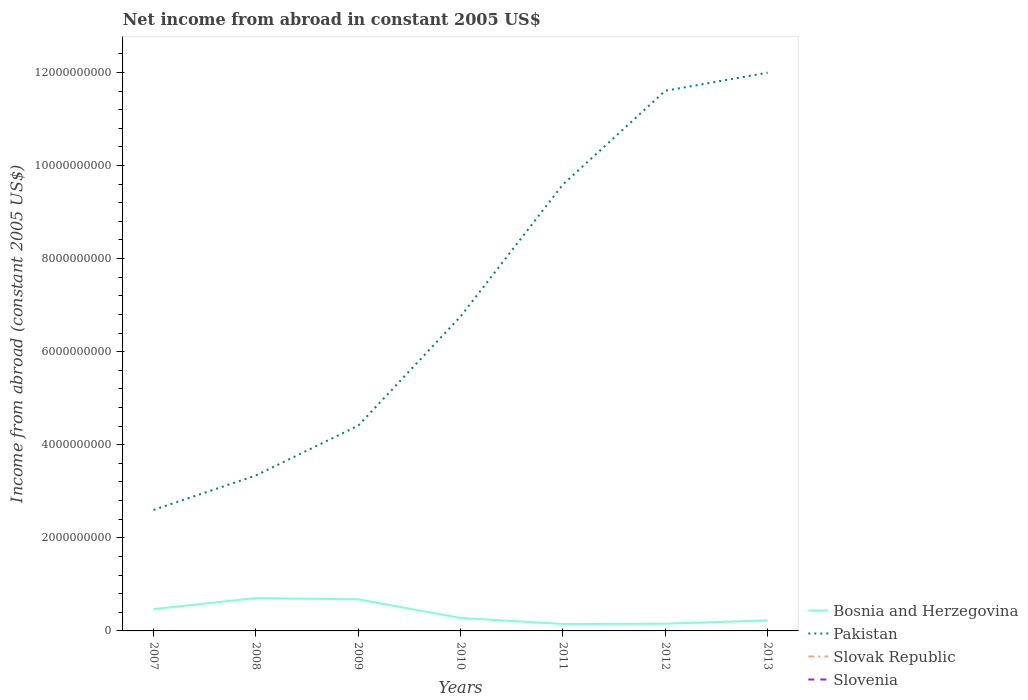How many different coloured lines are there?
Give a very brief answer. 2. Across all years, what is the maximum net income from abroad in Pakistan?
Offer a terse response. 2.60e+09. What is the total net income from abroad in Bosnia and Herzegovina in the graph?
Ensure brevity in your answer.  1.89e+08. What is the difference between the highest and the second highest net income from abroad in Bosnia and Herzegovina?
Your answer should be compact. 5.58e+08. What is the difference between the highest and the lowest net income from abroad in Slovenia?
Give a very brief answer. 0. Is the net income from abroad in Slovenia strictly greater than the net income from abroad in Slovak Republic over the years?
Provide a short and direct response. No. How many lines are there?
Make the answer very short. 2. What is the difference between two consecutive major ticks on the Y-axis?
Provide a succinct answer. 2.00e+09. Does the graph contain any zero values?
Make the answer very short. Yes. Does the graph contain grids?
Your answer should be compact. No. How many legend labels are there?
Offer a terse response. 4. How are the legend labels stacked?
Make the answer very short. Vertical. What is the title of the graph?
Your response must be concise. Net income from abroad in constant 2005 US$. Does "Australia" appear as one of the legend labels in the graph?
Give a very brief answer. No. What is the label or title of the Y-axis?
Your answer should be very brief. Income from abroad (constant 2005 US$). What is the Income from abroad (constant 2005 US$) of Bosnia and Herzegovina in 2007?
Keep it short and to the point. 4.69e+08. What is the Income from abroad (constant 2005 US$) of Pakistan in 2007?
Give a very brief answer. 2.60e+09. What is the Income from abroad (constant 2005 US$) of Slovak Republic in 2007?
Make the answer very short. 0. What is the Income from abroad (constant 2005 US$) in Slovenia in 2007?
Make the answer very short. 0. What is the Income from abroad (constant 2005 US$) of Bosnia and Herzegovina in 2008?
Your answer should be compact. 7.06e+08. What is the Income from abroad (constant 2005 US$) of Pakistan in 2008?
Offer a terse response. 3.34e+09. What is the Income from abroad (constant 2005 US$) in Slovak Republic in 2008?
Offer a very short reply. 0. What is the Income from abroad (constant 2005 US$) in Slovenia in 2008?
Keep it short and to the point. 0. What is the Income from abroad (constant 2005 US$) of Bosnia and Herzegovina in 2009?
Your answer should be very brief. 6.78e+08. What is the Income from abroad (constant 2005 US$) of Pakistan in 2009?
Your response must be concise. 4.41e+09. What is the Income from abroad (constant 2005 US$) in Slovenia in 2009?
Your answer should be very brief. 0. What is the Income from abroad (constant 2005 US$) of Bosnia and Herzegovina in 2010?
Make the answer very short. 2.79e+08. What is the Income from abroad (constant 2005 US$) in Pakistan in 2010?
Your answer should be compact. 6.76e+09. What is the Income from abroad (constant 2005 US$) of Slovenia in 2010?
Your response must be concise. 0. What is the Income from abroad (constant 2005 US$) in Bosnia and Herzegovina in 2011?
Offer a very short reply. 1.49e+08. What is the Income from abroad (constant 2005 US$) in Pakistan in 2011?
Your response must be concise. 9.59e+09. What is the Income from abroad (constant 2005 US$) in Bosnia and Herzegovina in 2012?
Your response must be concise. 1.55e+08. What is the Income from abroad (constant 2005 US$) in Pakistan in 2012?
Your response must be concise. 1.16e+1. What is the Income from abroad (constant 2005 US$) in Slovak Republic in 2012?
Your response must be concise. 0. What is the Income from abroad (constant 2005 US$) in Slovenia in 2012?
Your response must be concise. 0. What is the Income from abroad (constant 2005 US$) of Bosnia and Herzegovina in 2013?
Your answer should be very brief. 2.26e+08. What is the Income from abroad (constant 2005 US$) in Pakistan in 2013?
Give a very brief answer. 1.20e+1. What is the Income from abroad (constant 2005 US$) of Slovenia in 2013?
Make the answer very short. 0. Across all years, what is the maximum Income from abroad (constant 2005 US$) of Bosnia and Herzegovina?
Ensure brevity in your answer.  7.06e+08. Across all years, what is the maximum Income from abroad (constant 2005 US$) of Pakistan?
Your response must be concise. 1.20e+1. Across all years, what is the minimum Income from abroad (constant 2005 US$) in Bosnia and Herzegovina?
Provide a succinct answer. 1.49e+08. Across all years, what is the minimum Income from abroad (constant 2005 US$) of Pakistan?
Provide a short and direct response. 2.60e+09. What is the total Income from abroad (constant 2005 US$) in Bosnia and Herzegovina in the graph?
Make the answer very short. 2.66e+09. What is the total Income from abroad (constant 2005 US$) of Pakistan in the graph?
Provide a short and direct response. 5.03e+1. What is the total Income from abroad (constant 2005 US$) in Slovak Republic in the graph?
Keep it short and to the point. 0. What is the total Income from abroad (constant 2005 US$) of Slovenia in the graph?
Make the answer very short. 0. What is the difference between the Income from abroad (constant 2005 US$) of Bosnia and Herzegovina in 2007 and that in 2008?
Provide a succinct answer. -2.38e+08. What is the difference between the Income from abroad (constant 2005 US$) of Pakistan in 2007 and that in 2008?
Your answer should be compact. -7.40e+08. What is the difference between the Income from abroad (constant 2005 US$) of Bosnia and Herzegovina in 2007 and that in 2009?
Your answer should be compact. -2.10e+08. What is the difference between the Income from abroad (constant 2005 US$) in Pakistan in 2007 and that in 2009?
Ensure brevity in your answer.  -1.81e+09. What is the difference between the Income from abroad (constant 2005 US$) in Bosnia and Herzegovina in 2007 and that in 2010?
Provide a succinct answer. 1.89e+08. What is the difference between the Income from abroad (constant 2005 US$) in Pakistan in 2007 and that in 2010?
Give a very brief answer. -4.16e+09. What is the difference between the Income from abroad (constant 2005 US$) in Bosnia and Herzegovina in 2007 and that in 2011?
Provide a succinct answer. 3.20e+08. What is the difference between the Income from abroad (constant 2005 US$) of Pakistan in 2007 and that in 2011?
Offer a very short reply. -6.99e+09. What is the difference between the Income from abroad (constant 2005 US$) of Bosnia and Herzegovina in 2007 and that in 2012?
Offer a terse response. 3.14e+08. What is the difference between the Income from abroad (constant 2005 US$) in Pakistan in 2007 and that in 2012?
Your answer should be very brief. -9.01e+09. What is the difference between the Income from abroad (constant 2005 US$) of Bosnia and Herzegovina in 2007 and that in 2013?
Provide a succinct answer. 2.42e+08. What is the difference between the Income from abroad (constant 2005 US$) of Pakistan in 2007 and that in 2013?
Offer a terse response. -9.40e+09. What is the difference between the Income from abroad (constant 2005 US$) in Bosnia and Herzegovina in 2008 and that in 2009?
Provide a short and direct response. 2.77e+07. What is the difference between the Income from abroad (constant 2005 US$) of Pakistan in 2008 and that in 2009?
Your response must be concise. -1.07e+09. What is the difference between the Income from abroad (constant 2005 US$) of Bosnia and Herzegovina in 2008 and that in 2010?
Ensure brevity in your answer.  4.27e+08. What is the difference between the Income from abroad (constant 2005 US$) in Pakistan in 2008 and that in 2010?
Keep it short and to the point. -3.42e+09. What is the difference between the Income from abroad (constant 2005 US$) in Bosnia and Herzegovina in 2008 and that in 2011?
Offer a terse response. 5.58e+08. What is the difference between the Income from abroad (constant 2005 US$) of Pakistan in 2008 and that in 2011?
Give a very brief answer. -6.25e+09. What is the difference between the Income from abroad (constant 2005 US$) of Bosnia and Herzegovina in 2008 and that in 2012?
Provide a short and direct response. 5.52e+08. What is the difference between the Income from abroad (constant 2005 US$) of Pakistan in 2008 and that in 2012?
Your answer should be compact. -8.27e+09. What is the difference between the Income from abroad (constant 2005 US$) of Bosnia and Herzegovina in 2008 and that in 2013?
Ensure brevity in your answer.  4.80e+08. What is the difference between the Income from abroad (constant 2005 US$) of Pakistan in 2008 and that in 2013?
Provide a succinct answer. -8.65e+09. What is the difference between the Income from abroad (constant 2005 US$) of Bosnia and Herzegovina in 2009 and that in 2010?
Provide a short and direct response. 3.99e+08. What is the difference between the Income from abroad (constant 2005 US$) of Pakistan in 2009 and that in 2010?
Ensure brevity in your answer.  -2.35e+09. What is the difference between the Income from abroad (constant 2005 US$) of Bosnia and Herzegovina in 2009 and that in 2011?
Your response must be concise. 5.30e+08. What is the difference between the Income from abroad (constant 2005 US$) in Pakistan in 2009 and that in 2011?
Ensure brevity in your answer.  -5.18e+09. What is the difference between the Income from abroad (constant 2005 US$) in Bosnia and Herzegovina in 2009 and that in 2012?
Your answer should be very brief. 5.24e+08. What is the difference between the Income from abroad (constant 2005 US$) of Pakistan in 2009 and that in 2012?
Your answer should be very brief. -7.20e+09. What is the difference between the Income from abroad (constant 2005 US$) in Bosnia and Herzegovina in 2009 and that in 2013?
Your answer should be very brief. 4.52e+08. What is the difference between the Income from abroad (constant 2005 US$) of Pakistan in 2009 and that in 2013?
Give a very brief answer. -7.58e+09. What is the difference between the Income from abroad (constant 2005 US$) in Bosnia and Herzegovina in 2010 and that in 2011?
Offer a terse response. 1.31e+08. What is the difference between the Income from abroad (constant 2005 US$) of Pakistan in 2010 and that in 2011?
Ensure brevity in your answer.  -2.84e+09. What is the difference between the Income from abroad (constant 2005 US$) of Bosnia and Herzegovina in 2010 and that in 2012?
Your answer should be compact. 1.25e+08. What is the difference between the Income from abroad (constant 2005 US$) in Pakistan in 2010 and that in 2012?
Your answer should be very brief. -4.85e+09. What is the difference between the Income from abroad (constant 2005 US$) of Bosnia and Herzegovina in 2010 and that in 2013?
Provide a short and direct response. 5.29e+07. What is the difference between the Income from abroad (constant 2005 US$) in Pakistan in 2010 and that in 2013?
Offer a very short reply. -5.24e+09. What is the difference between the Income from abroad (constant 2005 US$) of Bosnia and Herzegovina in 2011 and that in 2012?
Your response must be concise. -6.13e+06. What is the difference between the Income from abroad (constant 2005 US$) of Pakistan in 2011 and that in 2012?
Your response must be concise. -2.01e+09. What is the difference between the Income from abroad (constant 2005 US$) in Bosnia and Herzegovina in 2011 and that in 2013?
Your response must be concise. -7.79e+07. What is the difference between the Income from abroad (constant 2005 US$) in Pakistan in 2011 and that in 2013?
Offer a terse response. -2.40e+09. What is the difference between the Income from abroad (constant 2005 US$) in Bosnia and Herzegovina in 2012 and that in 2013?
Provide a succinct answer. -7.17e+07. What is the difference between the Income from abroad (constant 2005 US$) of Pakistan in 2012 and that in 2013?
Give a very brief answer. -3.88e+08. What is the difference between the Income from abroad (constant 2005 US$) of Bosnia and Herzegovina in 2007 and the Income from abroad (constant 2005 US$) of Pakistan in 2008?
Make the answer very short. -2.87e+09. What is the difference between the Income from abroad (constant 2005 US$) of Bosnia and Herzegovina in 2007 and the Income from abroad (constant 2005 US$) of Pakistan in 2009?
Make the answer very short. -3.94e+09. What is the difference between the Income from abroad (constant 2005 US$) in Bosnia and Herzegovina in 2007 and the Income from abroad (constant 2005 US$) in Pakistan in 2010?
Your answer should be compact. -6.29e+09. What is the difference between the Income from abroad (constant 2005 US$) of Bosnia and Herzegovina in 2007 and the Income from abroad (constant 2005 US$) of Pakistan in 2011?
Keep it short and to the point. -9.12e+09. What is the difference between the Income from abroad (constant 2005 US$) of Bosnia and Herzegovina in 2007 and the Income from abroad (constant 2005 US$) of Pakistan in 2012?
Your answer should be very brief. -1.11e+1. What is the difference between the Income from abroad (constant 2005 US$) of Bosnia and Herzegovina in 2007 and the Income from abroad (constant 2005 US$) of Pakistan in 2013?
Your answer should be compact. -1.15e+1. What is the difference between the Income from abroad (constant 2005 US$) in Bosnia and Herzegovina in 2008 and the Income from abroad (constant 2005 US$) in Pakistan in 2009?
Offer a terse response. -3.71e+09. What is the difference between the Income from abroad (constant 2005 US$) in Bosnia and Herzegovina in 2008 and the Income from abroad (constant 2005 US$) in Pakistan in 2010?
Your response must be concise. -6.05e+09. What is the difference between the Income from abroad (constant 2005 US$) in Bosnia and Herzegovina in 2008 and the Income from abroad (constant 2005 US$) in Pakistan in 2011?
Your answer should be very brief. -8.89e+09. What is the difference between the Income from abroad (constant 2005 US$) of Bosnia and Herzegovina in 2008 and the Income from abroad (constant 2005 US$) of Pakistan in 2012?
Your response must be concise. -1.09e+1. What is the difference between the Income from abroad (constant 2005 US$) in Bosnia and Herzegovina in 2008 and the Income from abroad (constant 2005 US$) in Pakistan in 2013?
Provide a succinct answer. -1.13e+1. What is the difference between the Income from abroad (constant 2005 US$) of Bosnia and Herzegovina in 2009 and the Income from abroad (constant 2005 US$) of Pakistan in 2010?
Provide a short and direct response. -6.08e+09. What is the difference between the Income from abroad (constant 2005 US$) in Bosnia and Herzegovina in 2009 and the Income from abroad (constant 2005 US$) in Pakistan in 2011?
Your answer should be compact. -8.91e+09. What is the difference between the Income from abroad (constant 2005 US$) of Bosnia and Herzegovina in 2009 and the Income from abroad (constant 2005 US$) of Pakistan in 2012?
Your response must be concise. -1.09e+1. What is the difference between the Income from abroad (constant 2005 US$) of Bosnia and Herzegovina in 2009 and the Income from abroad (constant 2005 US$) of Pakistan in 2013?
Provide a succinct answer. -1.13e+1. What is the difference between the Income from abroad (constant 2005 US$) of Bosnia and Herzegovina in 2010 and the Income from abroad (constant 2005 US$) of Pakistan in 2011?
Offer a terse response. -9.31e+09. What is the difference between the Income from abroad (constant 2005 US$) in Bosnia and Herzegovina in 2010 and the Income from abroad (constant 2005 US$) in Pakistan in 2012?
Ensure brevity in your answer.  -1.13e+1. What is the difference between the Income from abroad (constant 2005 US$) in Bosnia and Herzegovina in 2010 and the Income from abroad (constant 2005 US$) in Pakistan in 2013?
Your answer should be very brief. -1.17e+1. What is the difference between the Income from abroad (constant 2005 US$) of Bosnia and Herzegovina in 2011 and the Income from abroad (constant 2005 US$) of Pakistan in 2012?
Keep it short and to the point. -1.15e+1. What is the difference between the Income from abroad (constant 2005 US$) of Bosnia and Herzegovina in 2011 and the Income from abroad (constant 2005 US$) of Pakistan in 2013?
Offer a very short reply. -1.18e+1. What is the difference between the Income from abroad (constant 2005 US$) of Bosnia and Herzegovina in 2012 and the Income from abroad (constant 2005 US$) of Pakistan in 2013?
Ensure brevity in your answer.  -1.18e+1. What is the average Income from abroad (constant 2005 US$) of Bosnia and Herzegovina per year?
Make the answer very short. 3.80e+08. What is the average Income from abroad (constant 2005 US$) of Pakistan per year?
Provide a succinct answer. 7.19e+09. What is the average Income from abroad (constant 2005 US$) in Slovak Republic per year?
Your answer should be compact. 0. What is the average Income from abroad (constant 2005 US$) of Slovenia per year?
Offer a terse response. 0. In the year 2007, what is the difference between the Income from abroad (constant 2005 US$) of Bosnia and Herzegovina and Income from abroad (constant 2005 US$) of Pakistan?
Offer a very short reply. -2.13e+09. In the year 2008, what is the difference between the Income from abroad (constant 2005 US$) of Bosnia and Herzegovina and Income from abroad (constant 2005 US$) of Pakistan?
Your response must be concise. -2.63e+09. In the year 2009, what is the difference between the Income from abroad (constant 2005 US$) in Bosnia and Herzegovina and Income from abroad (constant 2005 US$) in Pakistan?
Ensure brevity in your answer.  -3.73e+09. In the year 2010, what is the difference between the Income from abroad (constant 2005 US$) of Bosnia and Herzegovina and Income from abroad (constant 2005 US$) of Pakistan?
Make the answer very short. -6.48e+09. In the year 2011, what is the difference between the Income from abroad (constant 2005 US$) in Bosnia and Herzegovina and Income from abroad (constant 2005 US$) in Pakistan?
Ensure brevity in your answer.  -9.44e+09. In the year 2012, what is the difference between the Income from abroad (constant 2005 US$) of Bosnia and Herzegovina and Income from abroad (constant 2005 US$) of Pakistan?
Offer a terse response. -1.15e+1. In the year 2013, what is the difference between the Income from abroad (constant 2005 US$) in Bosnia and Herzegovina and Income from abroad (constant 2005 US$) in Pakistan?
Keep it short and to the point. -1.18e+1. What is the ratio of the Income from abroad (constant 2005 US$) of Bosnia and Herzegovina in 2007 to that in 2008?
Your answer should be very brief. 0.66. What is the ratio of the Income from abroad (constant 2005 US$) of Pakistan in 2007 to that in 2008?
Your answer should be compact. 0.78. What is the ratio of the Income from abroad (constant 2005 US$) of Bosnia and Herzegovina in 2007 to that in 2009?
Offer a terse response. 0.69. What is the ratio of the Income from abroad (constant 2005 US$) of Pakistan in 2007 to that in 2009?
Ensure brevity in your answer.  0.59. What is the ratio of the Income from abroad (constant 2005 US$) in Bosnia and Herzegovina in 2007 to that in 2010?
Ensure brevity in your answer.  1.68. What is the ratio of the Income from abroad (constant 2005 US$) of Pakistan in 2007 to that in 2010?
Give a very brief answer. 0.38. What is the ratio of the Income from abroad (constant 2005 US$) of Bosnia and Herzegovina in 2007 to that in 2011?
Offer a very short reply. 3.15. What is the ratio of the Income from abroad (constant 2005 US$) of Pakistan in 2007 to that in 2011?
Provide a short and direct response. 0.27. What is the ratio of the Income from abroad (constant 2005 US$) of Bosnia and Herzegovina in 2007 to that in 2012?
Offer a terse response. 3.03. What is the ratio of the Income from abroad (constant 2005 US$) in Pakistan in 2007 to that in 2012?
Offer a very short reply. 0.22. What is the ratio of the Income from abroad (constant 2005 US$) in Bosnia and Herzegovina in 2007 to that in 2013?
Your response must be concise. 2.07. What is the ratio of the Income from abroad (constant 2005 US$) in Pakistan in 2007 to that in 2013?
Provide a short and direct response. 0.22. What is the ratio of the Income from abroad (constant 2005 US$) of Bosnia and Herzegovina in 2008 to that in 2009?
Your answer should be compact. 1.04. What is the ratio of the Income from abroad (constant 2005 US$) of Pakistan in 2008 to that in 2009?
Ensure brevity in your answer.  0.76. What is the ratio of the Income from abroad (constant 2005 US$) of Bosnia and Herzegovina in 2008 to that in 2010?
Give a very brief answer. 2.53. What is the ratio of the Income from abroad (constant 2005 US$) in Pakistan in 2008 to that in 2010?
Offer a very short reply. 0.49. What is the ratio of the Income from abroad (constant 2005 US$) in Bosnia and Herzegovina in 2008 to that in 2011?
Keep it short and to the point. 4.75. What is the ratio of the Income from abroad (constant 2005 US$) of Pakistan in 2008 to that in 2011?
Keep it short and to the point. 0.35. What is the ratio of the Income from abroad (constant 2005 US$) in Bosnia and Herzegovina in 2008 to that in 2012?
Your answer should be very brief. 4.57. What is the ratio of the Income from abroad (constant 2005 US$) in Pakistan in 2008 to that in 2012?
Provide a short and direct response. 0.29. What is the ratio of the Income from abroad (constant 2005 US$) in Bosnia and Herzegovina in 2008 to that in 2013?
Give a very brief answer. 3.12. What is the ratio of the Income from abroad (constant 2005 US$) of Pakistan in 2008 to that in 2013?
Keep it short and to the point. 0.28. What is the ratio of the Income from abroad (constant 2005 US$) of Bosnia and Herzegovina in 2009 to that in 2010?
Offer a very short reply. 2.43. What is the ratio of the Income from abroad (constant 2005 US$) in Pakistan in 2009 to that in 2010?
Offer a terse response. 0.65. What is the ratio of the Income from abroad (constant 2005 US$) of Bosnia and Herzegovina in 2009 to that in 2011?
Your answer should be very brief. 4.57. What is the ratio of the Income from abroad (constant 2005 US$) of Pakistan in 2009 to that in 2011?
Your answer should be very brief. 0.46. What is the ratio of the Income from abroad (constant 2005 US$) of Bosnia and Herzegovina in 2009 to that in 2012?
Provide a short and direct response. 4.39. What is the ratio of the Income from abroad (constant 2005 US$) in Pakistan in 2009 to that in 2012?
Offer a very short reply. 0.38. What is the ratio of the Income from abroad (constant 2005 US$) in Bosnia and Herzegovina in 2009 to that in 2013?
Your answer should be compact. 3. What is the ratio of the Income from abroad (constant 2005 US$) of Pakistan in 2009 to that in 2013?
Give a very brief answer. 0.37. What is the ratio of the Income from abroad (constant 2005 US$) in Bosnia and Herzegovina in 2010 to that in 2011?
Ensure brevity in your answer.  1.88. What is the ratio of the Income from abroad (constant 2005 US$) of Pakistan in 2010 to that in 2011?
Give a very brief answer. 0.7. What is the ratio of the Income from abroad (constant 2005 US$) of Bosnia and Herzegovina in 2010 to that in 2012?
Make the answer very short. 1.81. What is the ratio of the Income from abroad (constant 2005 US$) in Pakistan in 2010 to that in 2012?
Your answer should be compact. 0.58. What is the ratio of the Income from abroad (constant 2005 US$) in Bosnia and Herzegovina in 2010 to that in 2013?
Ensure brevity in your answer.  1.23. What is the ratio of the Income from abroad (constant 2005 US$) in Pakistan in 2010 to that in 2013?
Provide a succinct answer. 0.56. What is the ratio of the Income from abroad (constant 2005 US$) of Bosnia and Herzegovina in 2011 to that in 2012?
Your answer should be compact. 0.96. What is the ratio of the Income from abroad (constant 2005 US$) in Pakistan in 2011 to that in 2012?
Ensure brevity in your answer.  0.83. What is the ratio of the Income from abroad (constant 2005 US$) of Bosnia and Herzegovina in 2011 to that in 2013?
Offer a very short reply. 0.66. What is the ratio of the Income from abroad (constant 2005 US$) of Pakistan in 2011 to that in 2013?
Ensure brevity in your answer.  0.8. What is the ratio of the Income from abroad (constant 2005 US$) of Bosnia and Herzegovina in 2012 to that in 2013?
Give a very brief answer. 0.68. What is the ratio of the Income from abroad (constant 2005 US$) in Pakistan in 2012 to that in 2013?
Offer a terse response. 0.97. What is the difference between the highest and the second highest Income from abroad (constant 2005 US$) of Bosnia and Herzegovina?
Provide a short and direct response. 2.77e+07. What is the difference between the highest and the second highest Income from abroad (constant 2005 US$) in Pakistan?
Provide a short and direct response. 3.88e+08. What is the difference between the highest and the lowest Income from abroad (constant 2005 US$) in Bosnia and Herzegovina?
Your answer should be compact. 5.58e+08. What is the difference between the highest and the lowest Income from abroad (constant 2005 US$) in Pakistan?
Keep it short and to the point. 9.40e+09. 